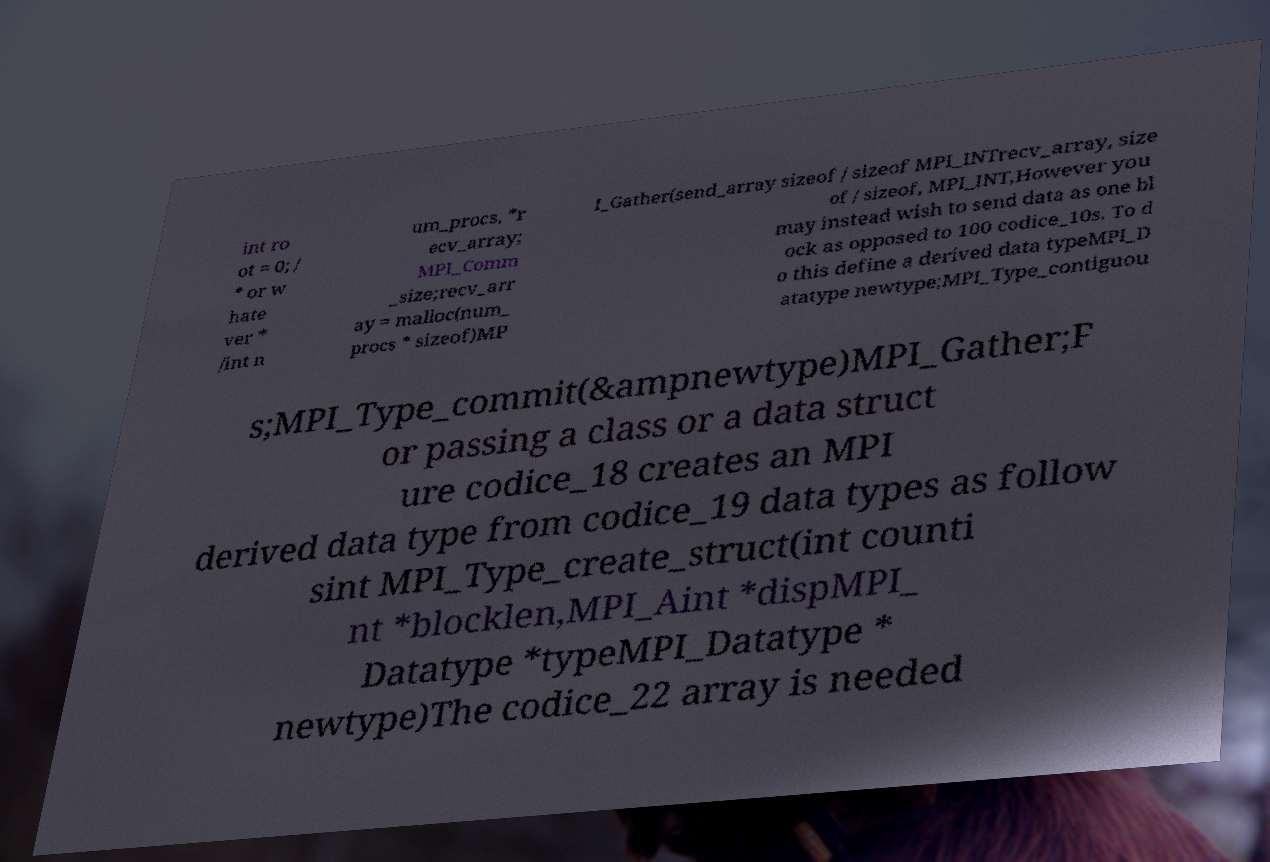Can you read and provide the text displayed in the image?This photo seems to have some interesting text. Can you extract and type it out for me? int ro ot = 0; / * or w hate ver * /int n um_procs, *r ecv_array; MPI_Comm _size;recv_arr ay = malloc(num_ procs * sizeof)MP I_Gather(send_array sizeof / sizeof MPI_INTrecv_array, size of / sizeof, MPI_INT,However you may instead wish to send data as one bl ock as opposed to 100 codice_10s. To d o this define a derived data typeMPI_D atatype newtype;MPI_Type_contiguou s;MPI_Type_commit(&ampnewtype)MPI_Gather;F or passing a class or a data struct ure codice_18 creates an MPI derived data type from codice_19 data types as follow sint MPI_Type_create_struct(int counti nt *blocklen,MPI_Aint *dispMPI_ Datatype *typeMPI_Datatype * newtype)The codice_22 array is needed 